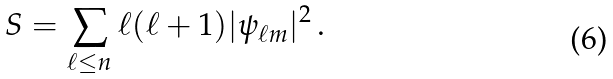Convert formula to latex. <formula><loc_0><loc_0><loc_500><loc_500>S = \sum _ { \ell \leq n } \ell ( \ell + 1 ) | \psi _ { \ell m } | ^ { 2 } \, .</formula> 